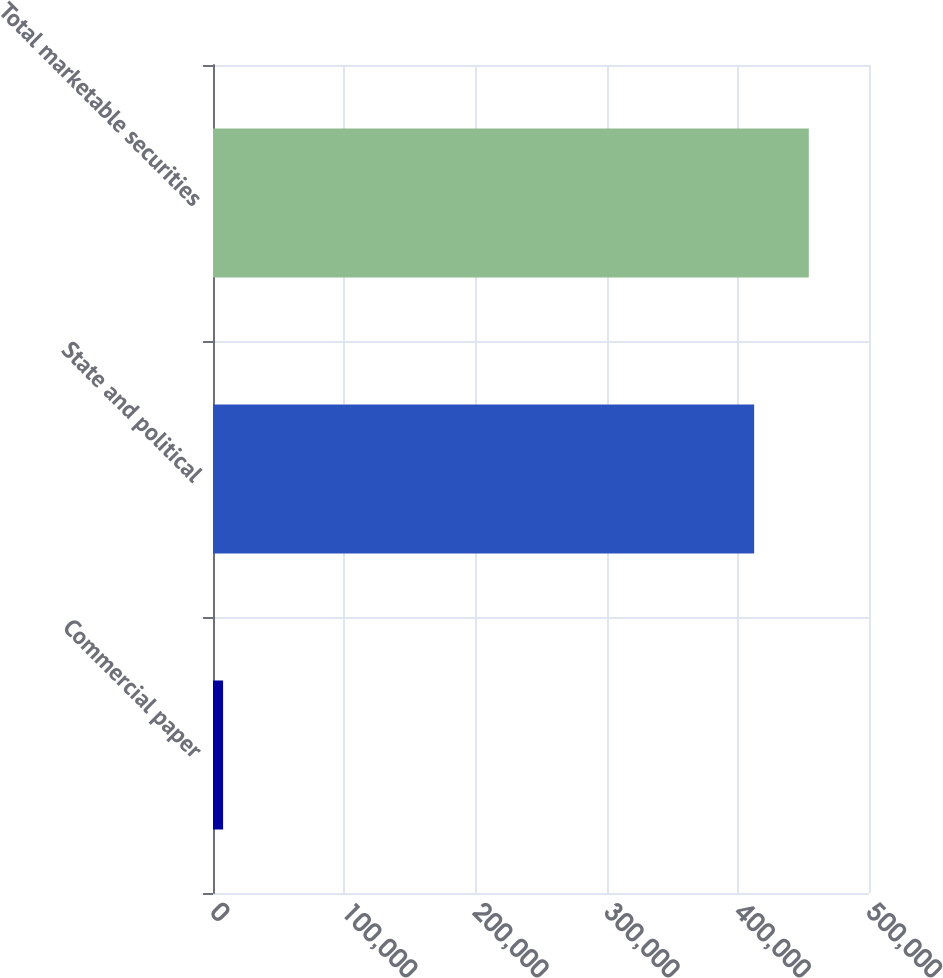<chart> <loc_0><loc_0><loc_500><loc_500><bar_chart><fcel>Commercial paper<fcel>State and political<fcel>Total marketable securities<nl><fcel>7687<fcel>412462<fcel>454108<nl></chart> 